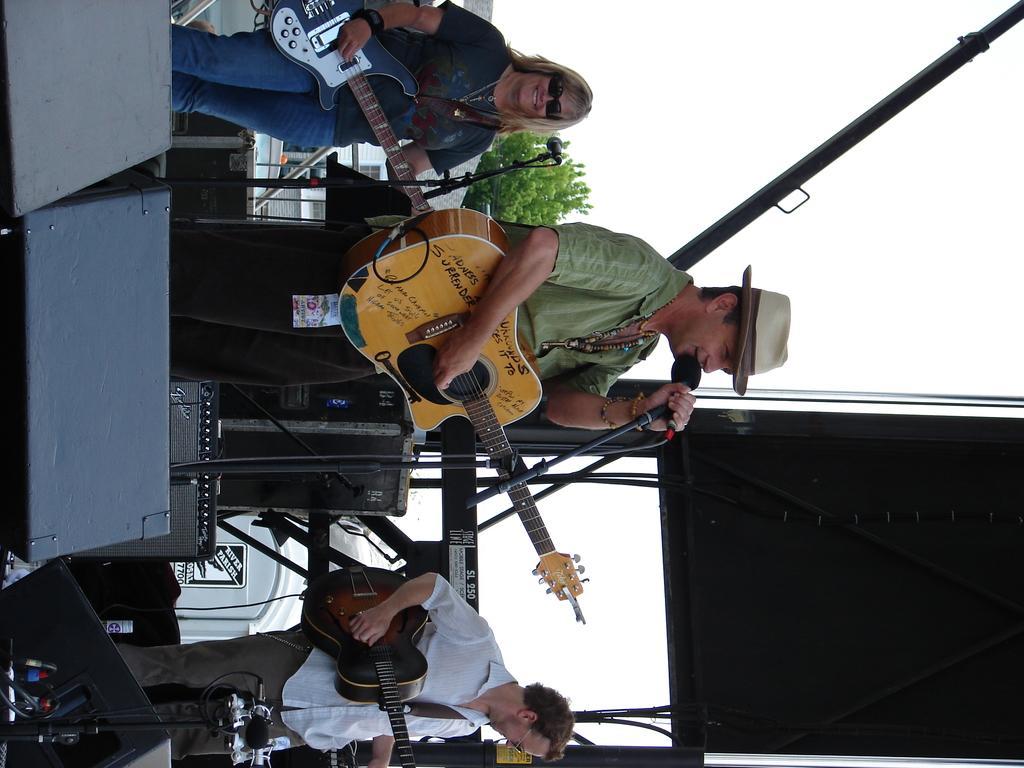How would you summarize this image in a sentence or two? In this image there are musicians standing and performing. In the center a man wearing a hat is holding a guitar and a mic in his hand. At the left side the woman wearing a black colour t-shirt is holding guitar in her hand and is having smile on her face. At the right side the man wearing a white colour shirt is holding guitar in his hand. In the background there are some speakers and a black colour screen. There is a sky and trees and a building. 